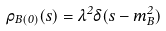Convert formula to latex. <formula><loc_0><loc_0><loc_500><loc_500>\rho _ { B ( 0 ) } ( s ) = \lambda ^ { 2 } \delta ( s - m _ { B } ^ { 2 } )</formula> 